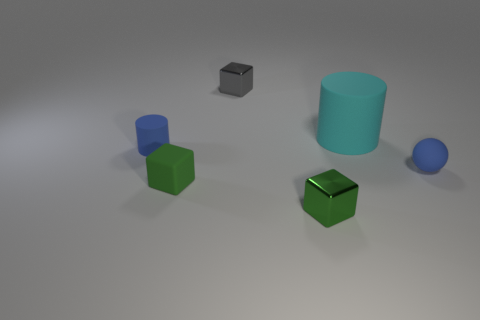Add 1 small shiny objects. How many objects exist? 7 Subtract all balls. How many objects are left? 5 Add 5 blue cylinders. How many blue cylinders exist? 6 Subtract 0 purple cubes. How many objects are left? 6 Subtract all tiny blue metal cylinders. Subtract all cyan things. How many objects are left? 5 Add 6 green objects. How many green objects are left? 8 